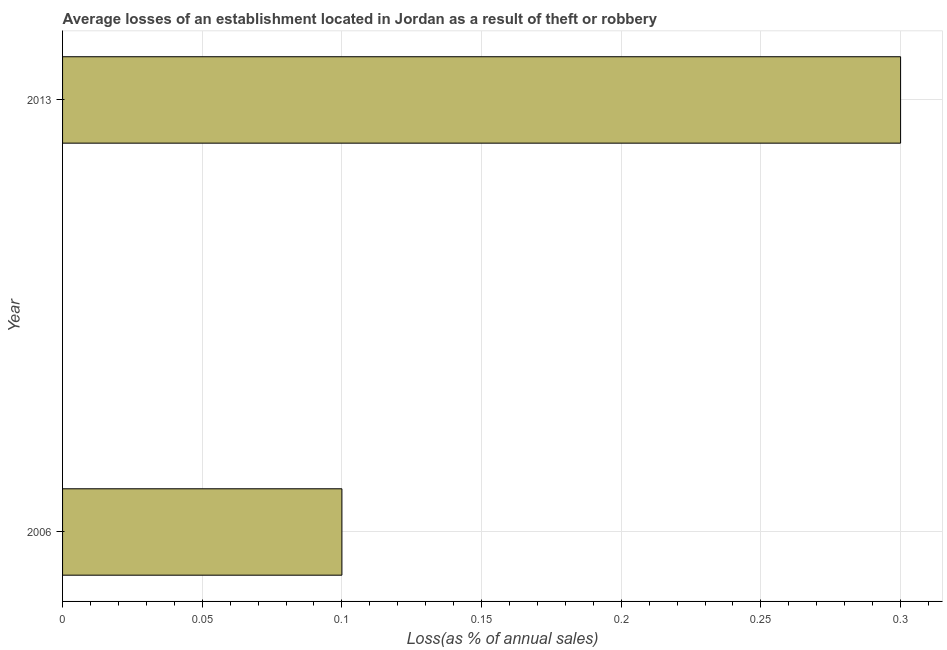What is the title of the graph?
Offer a terse response. Average losses of an establishment located in Jordan as a result of theft or robbery. What is the label or title of the X-axis?
Keep it short and to the point. Loss(as % of annual sales). What is the losses due to theft in 2013?
Your response must be concise. 0.3. Across all years, what is the maximum losses due to theft?
Your answer should be compact. 0.3. Across all years, what is the minimum losses due to theft?
Ensure brevity in your answer.  0.1. What is the difference between the losses due to theft in 2006 and 2013?
Ensure brevity in your answer.  -0.2. What is the average losses due to theft per year?
Your answer should be compact. 0.2. What is the median losses due to theft?
Offer a very short reply. 0.2. In how many years, is the losses due to theft greater than 0.02 %?
Provide a succinct answer. 2. What is the ratio of the losses due to theft in 2006 to that in 2013?
Make the answer very short. 0.33. Is the losses due to theft in 2006 less than that in 2013?
Give a very brief answer. Yes. In how many years, is the losses due to theft greater than the average losses due to theft taken over all years?
Provide a succinct answer. 1. How many bars are there?
Offer a very short reply. 2. What is the difference between two consecutive major ticks on the X-axis?
Keep it short and to the point. 0.05. What is the Loss(as % of annual sales) in 2006?
Keep it short and to the point. 0.1. What is the difference between the Loss(as % of annual sales) in 2006 and 2013?
Keep it short and to the point. -0.2. What is the ratio of the Loss(as % of annual sales) in 2006 to that in 2013?
Ensure brevity in your answer.  0.33. 